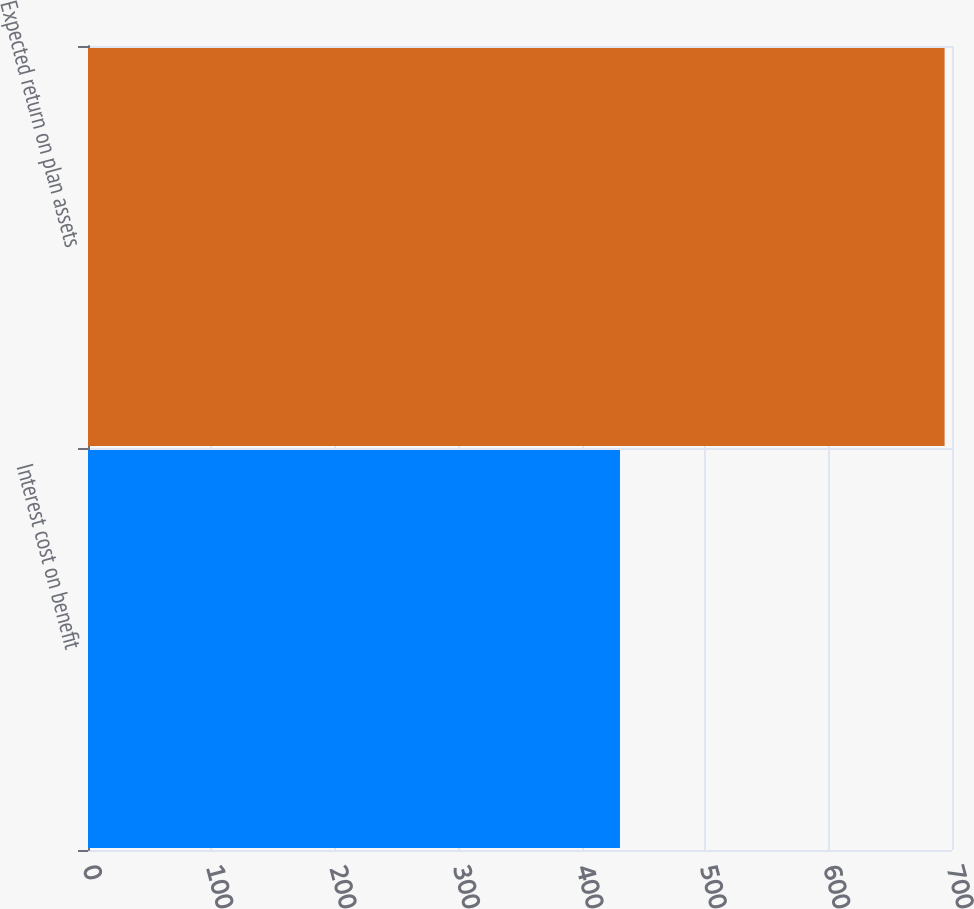Convert chart. <chart><loc_0><loc_0><loc_500><loc_500><bar_chart><fcel>Interest cost on benefit<fcel>Expected return on plan assets<nl><fcel>431<fcel>694<nl></chart> 